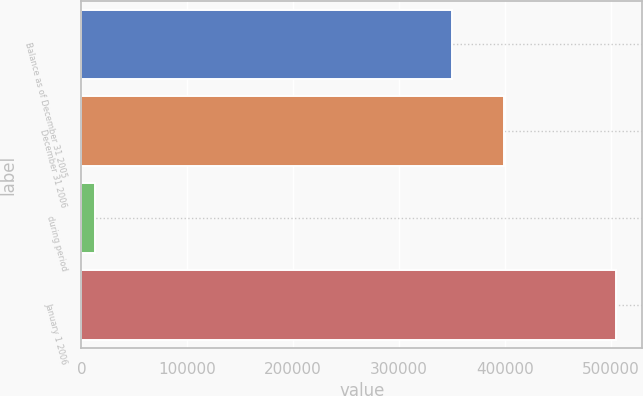<chart> <loc_0><loc_0><loc_500><loc_500><bar_chart><fcel>Balance as of December 31 2005<fcel>December 31 2006<fcel>during period<fcel>January 1 2006<nl><fcel>349814<fcel>398942<fcel>13257<fcel>504534<nl></chart> 